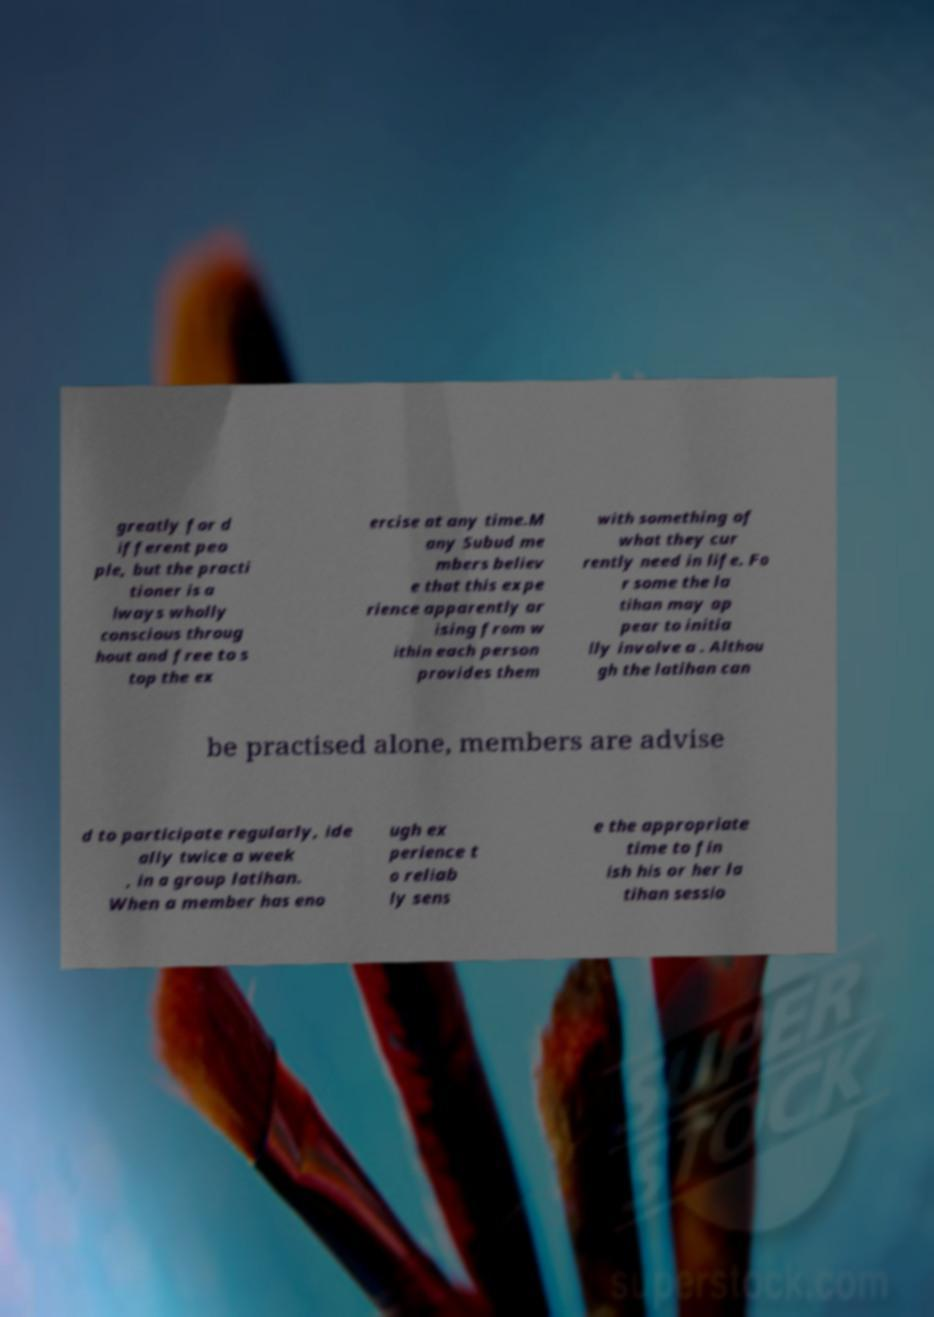Can you accurately transcribe the text from the provided image for me? greatly for d ifferent peo ple, but the practi tioner is a lways wholly conscious throug hout and free to s top the ex ercise at any time.M any Subud me mbers believ e that this expe rience apparently ar ising from w ithin each person provides them with something of what they cur rently need in life. Fo r some the la tihan may ap pear to initia lly involve a . Althou gh the latihan can be practised alone, members are advise d to participate regularly, ide ally twice a week , in a group latihan. When a member has eno ugh ex perience t o reliab ly sens e the appropriate time to fin ish his or her la tihan sessio 